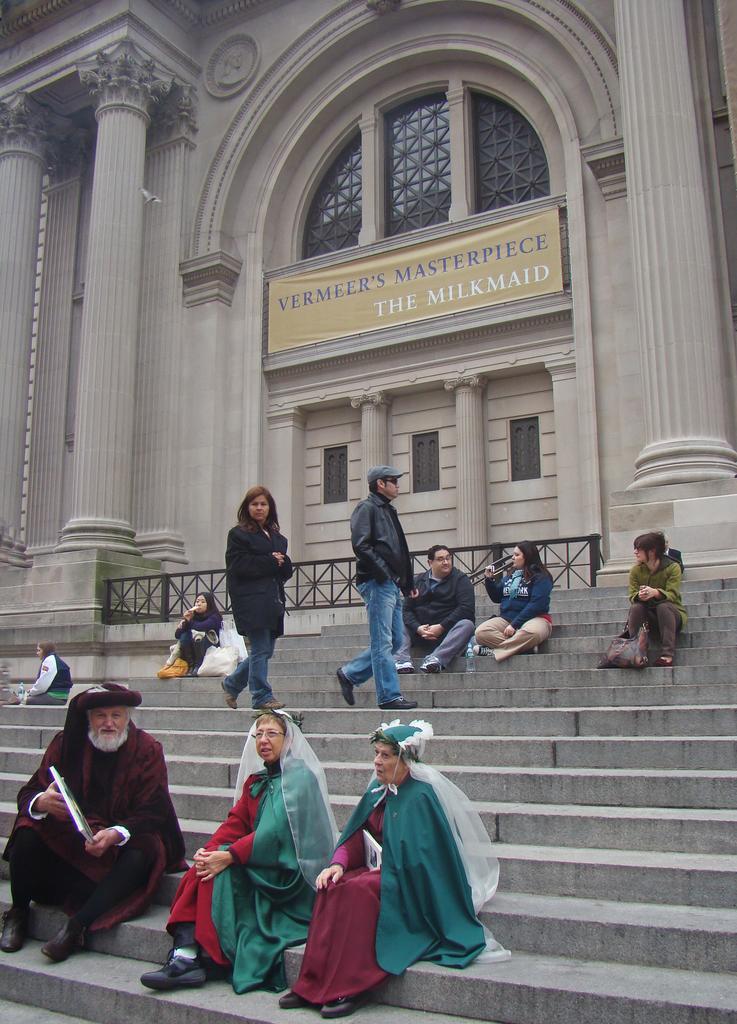Describe this image in one or two sentences. In the down side 2 women are sitting on the stairs, they wore dark red and green color dresses. In the left side there is an old man. In the middle a man and woman are walking on the stairs and there is a banner on this building. 